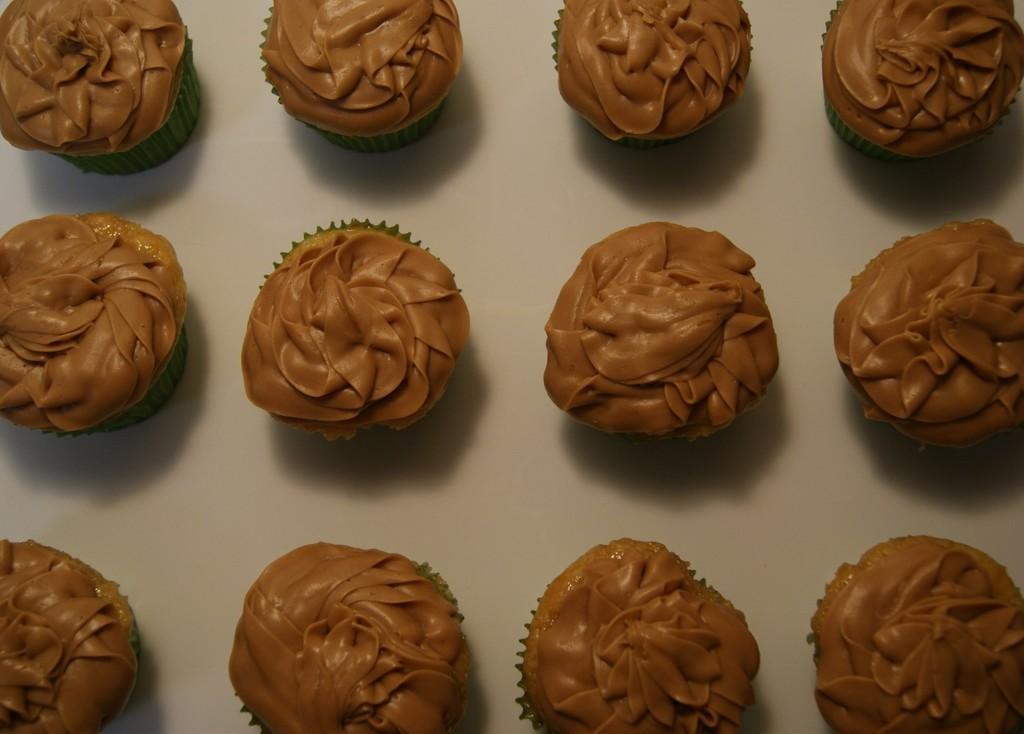Describe this image in one or two sentences. In this image we can see cupcakes on the white surface. 